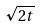<formula> <loc_0><loc_0><loc_500><loc_500>\sqrt { 2 t }</formula> 